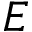Convert formula to latex. <formula><loc_0><loc_0><loc_500><loc_500>E</formula> 